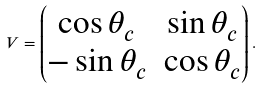<formula> <loc_0><loc_0><loc_500><loc_500>V = \begin{pmatrix} \cos { \theta _ { c } } & \sin { \theta _ { c } } \\ - \sin { \theta _ { c } } & \cos { \theta _ { c } } \end{pmatrix} .</formula> 